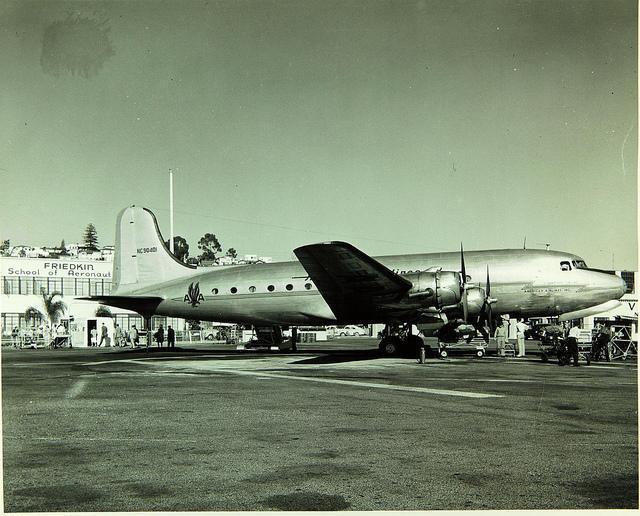Is the statement "The airplane is behind the truck." accurate regarding the image?
Answer yes or no. No. 